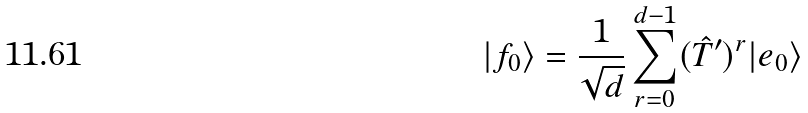<formula> <loc_0><loc_0><loc_500><loc_500>| f _ { 0 } \rangle = \frac { 1 } { \sqrt { d } } \sum _ { r = 0 } ^ { d - 1 } ( \hat { T } ^ { \prime } ) ^ { r } | e _ { 0 } \rangle</formula> 